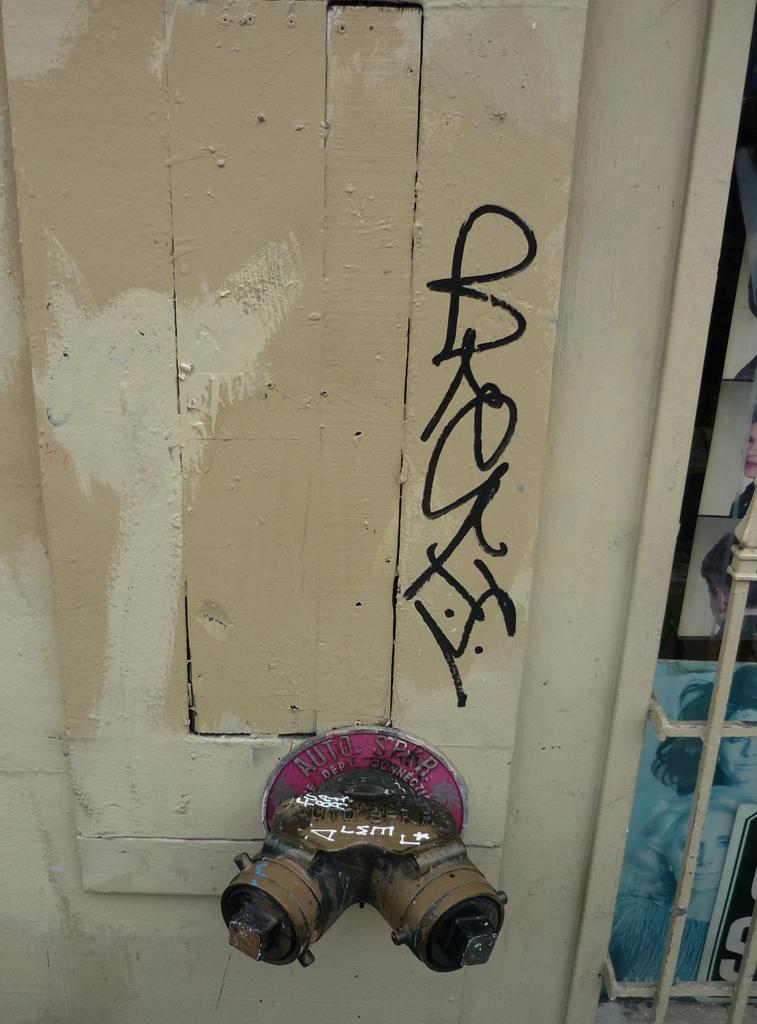What is the main object in the image that has text on it? There is a wooden plank with text in the image. What type of material is the metal object made of? The metal object in the image is made of metal. What can be seen in the photos in the image? The content of the photos in the image cannot be determined from the provided facts. Can you describe any other objects present in the image? There are other objects present in the image, but their specific details cannot be determined from the provided facts. What type of rhythm does the actor perform in the image? There is no actor or rhythm present in the image; it features a wooden plank with text, a metal object, and photos. 